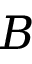<formula> <loc_0><loc_0><loc_500><loc_500>B</formula> 